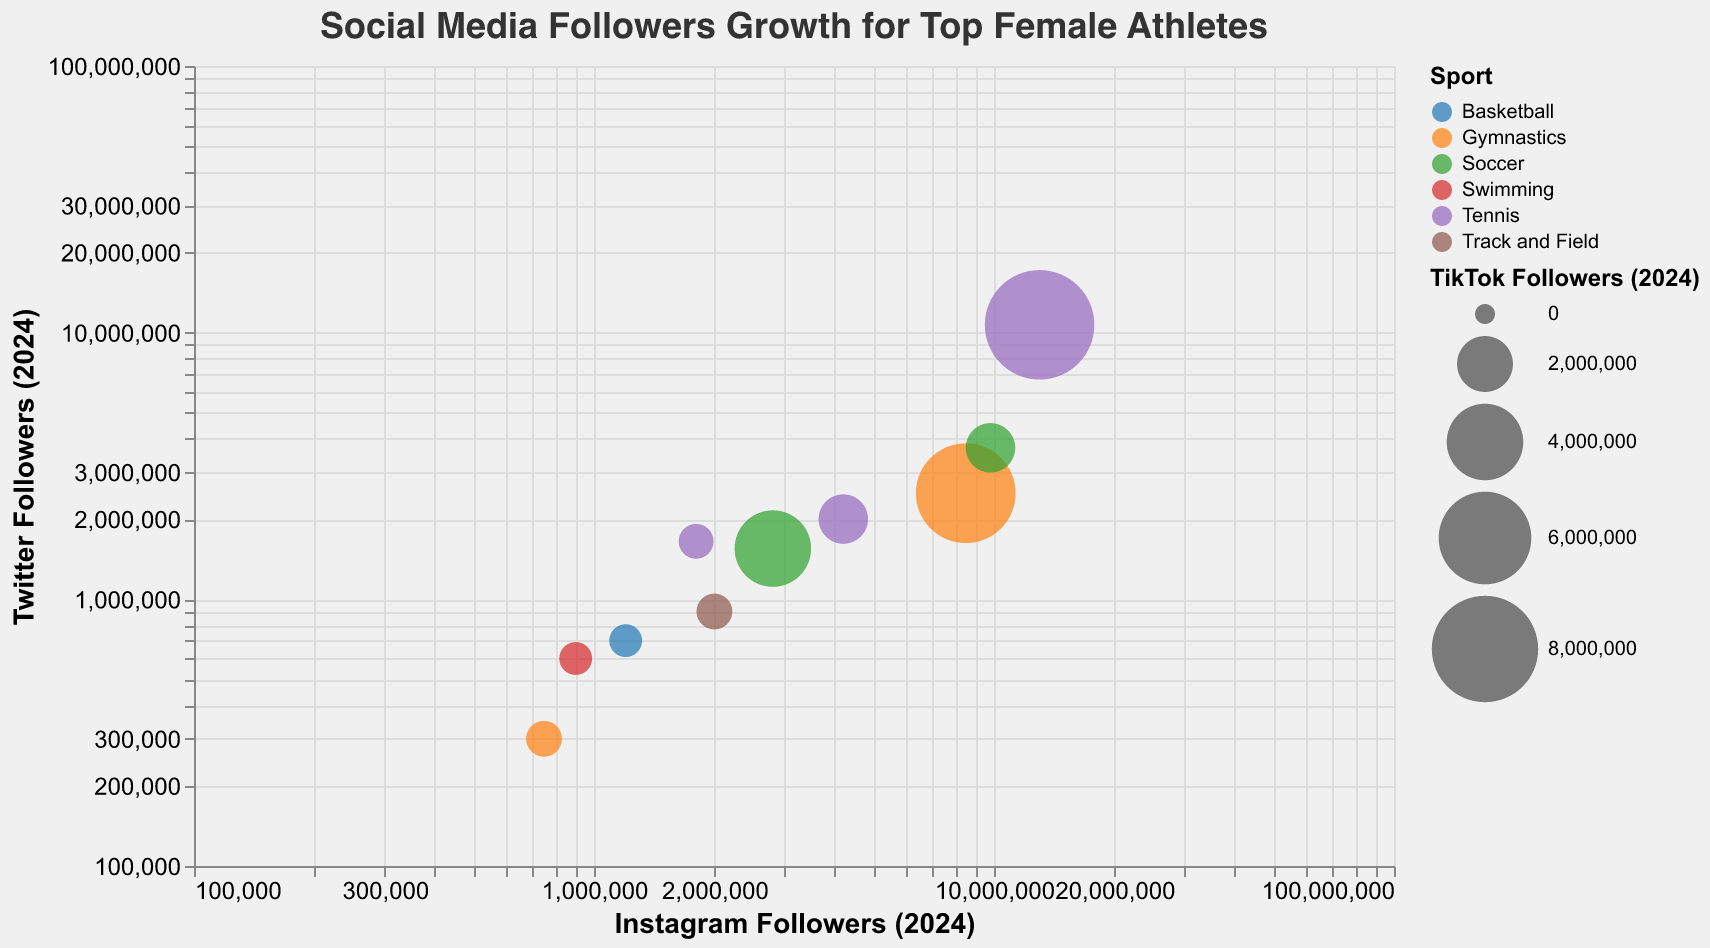How many followers does Nataliia Lagutenko have on Instagram in 2024? Look for Nataliia Lagutenko's Instagram followers in 2024 on the x-axis and read the value.
Answer: 750,000 Which athlete has the highest number of TikTok followers in 2024, and what sport do they play? Compare the sizes of the bubbles, as the size represents the number of TikTok followers, and identify the largest bubble.
Answer: Serena Williams, Tennis Who has more Twitter followers in 2024, Nataliia Lagutenko or Katie Ledecky? Check the positions of Nataliia Lagutenko and Katie Ledecky along the y-axis, which represents Twitter followers in 2024.
Answer: Nataliia Lagutenko Which sports are represented in the chart? Look at the legend which describes the color coding of different sports in the figure.
Answer: Gymnastics, Tennis, Soccer, Swimming, Basketball, Track and Field What is the difference in Instagram followers between Naomi Osaka and Megan Rapinoe in 2024? Note the Instagram followers for Naomi Osaka and Megan Rapinoe from their x-coordinates and subtract the smaller value from the larger value.
Answer: 1,400,000 Which athlete gained the most followers on Instagram from 2023 to 2024? Calculate the difference in Instagram followers from 2023 to 2024 for each athlete and identify the one with the largest increase.
Answer: Naomi Osaka What is the relationship between the Twitter followers of Serena Williams and Venus Williams in 2024? Compare the y-coordinates of Serena Williams and Venus Williams to compare their Twitter followers in 2024.
Answer: Serena Williams has more Twitter followers than Venus Williams In which platform did Nataliia Lagutenko see the highest growth in followers from 2023 to 2024? Compare the increase in followers from 2023 to 2024 for Instagram, Twitter, and TikTok for Nataliia Lagutenko.
Answer: Instagram How does the number of Instagram followers of Simone Biles in 2024 compare to her Twitter followers? Compare Simone Biles' Instagram followers along the x-axis to her Twitter followers along the y-axis for 2024.
Answer: Greater on Instagram 